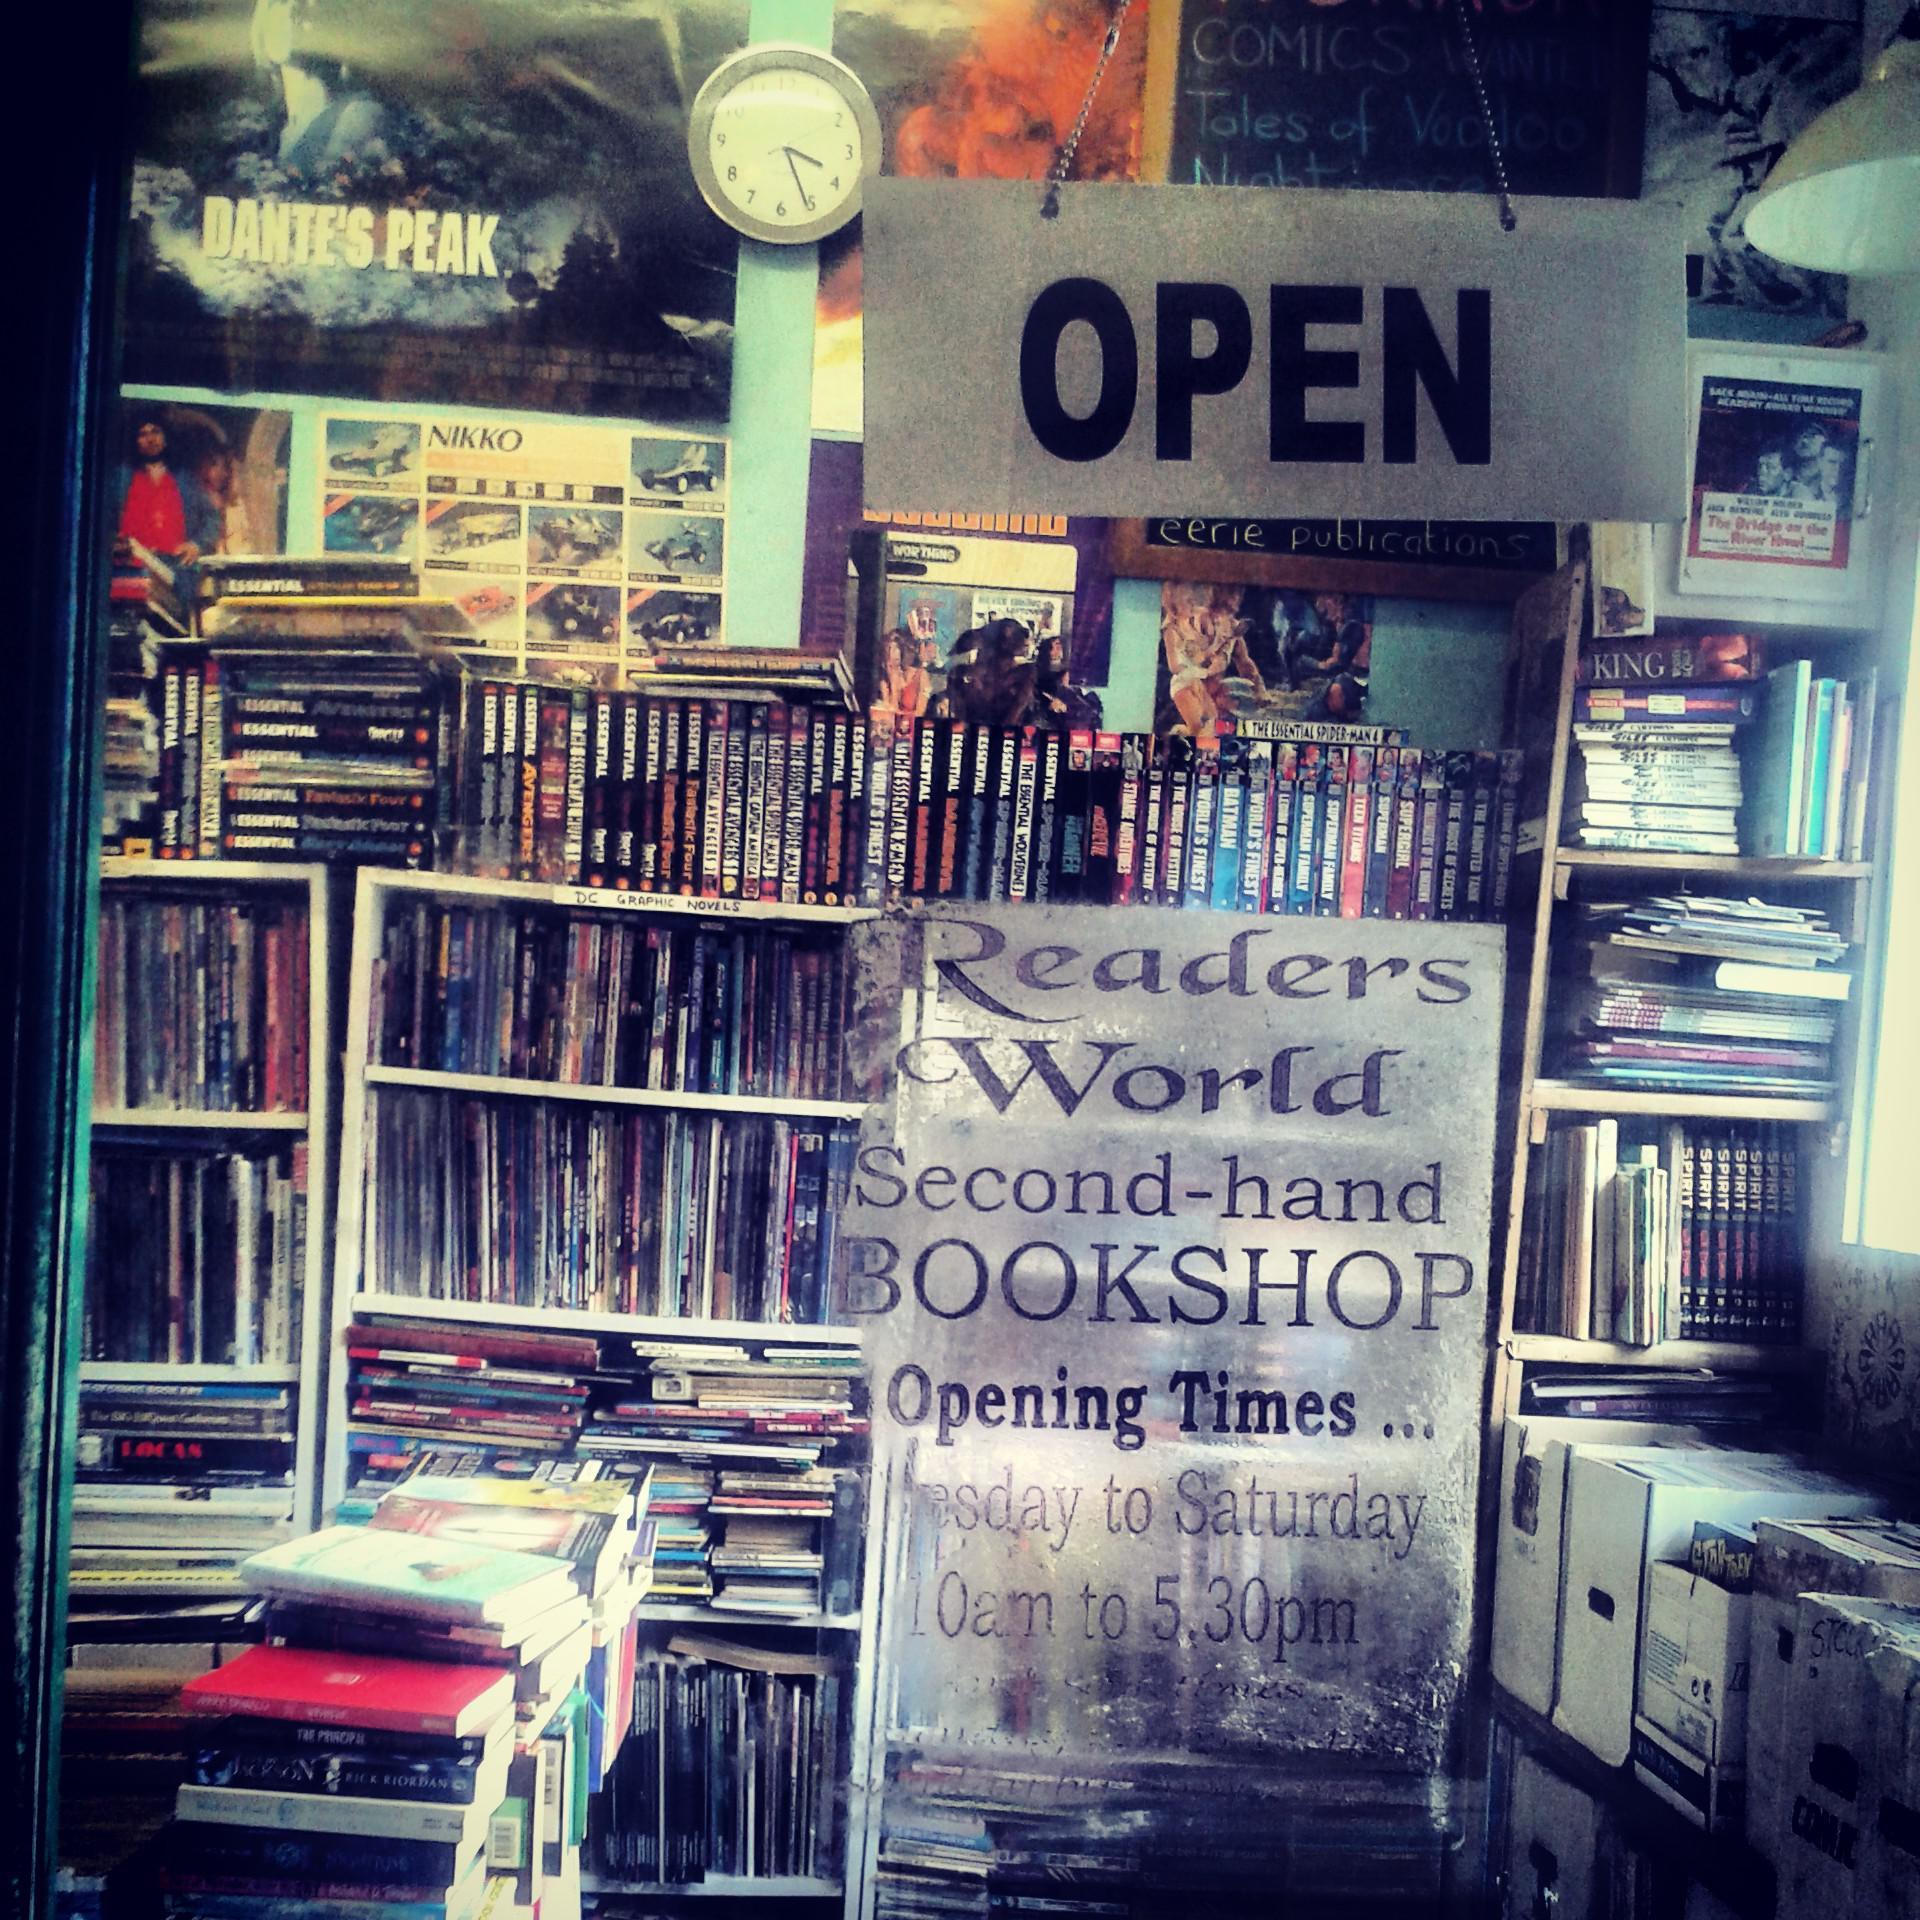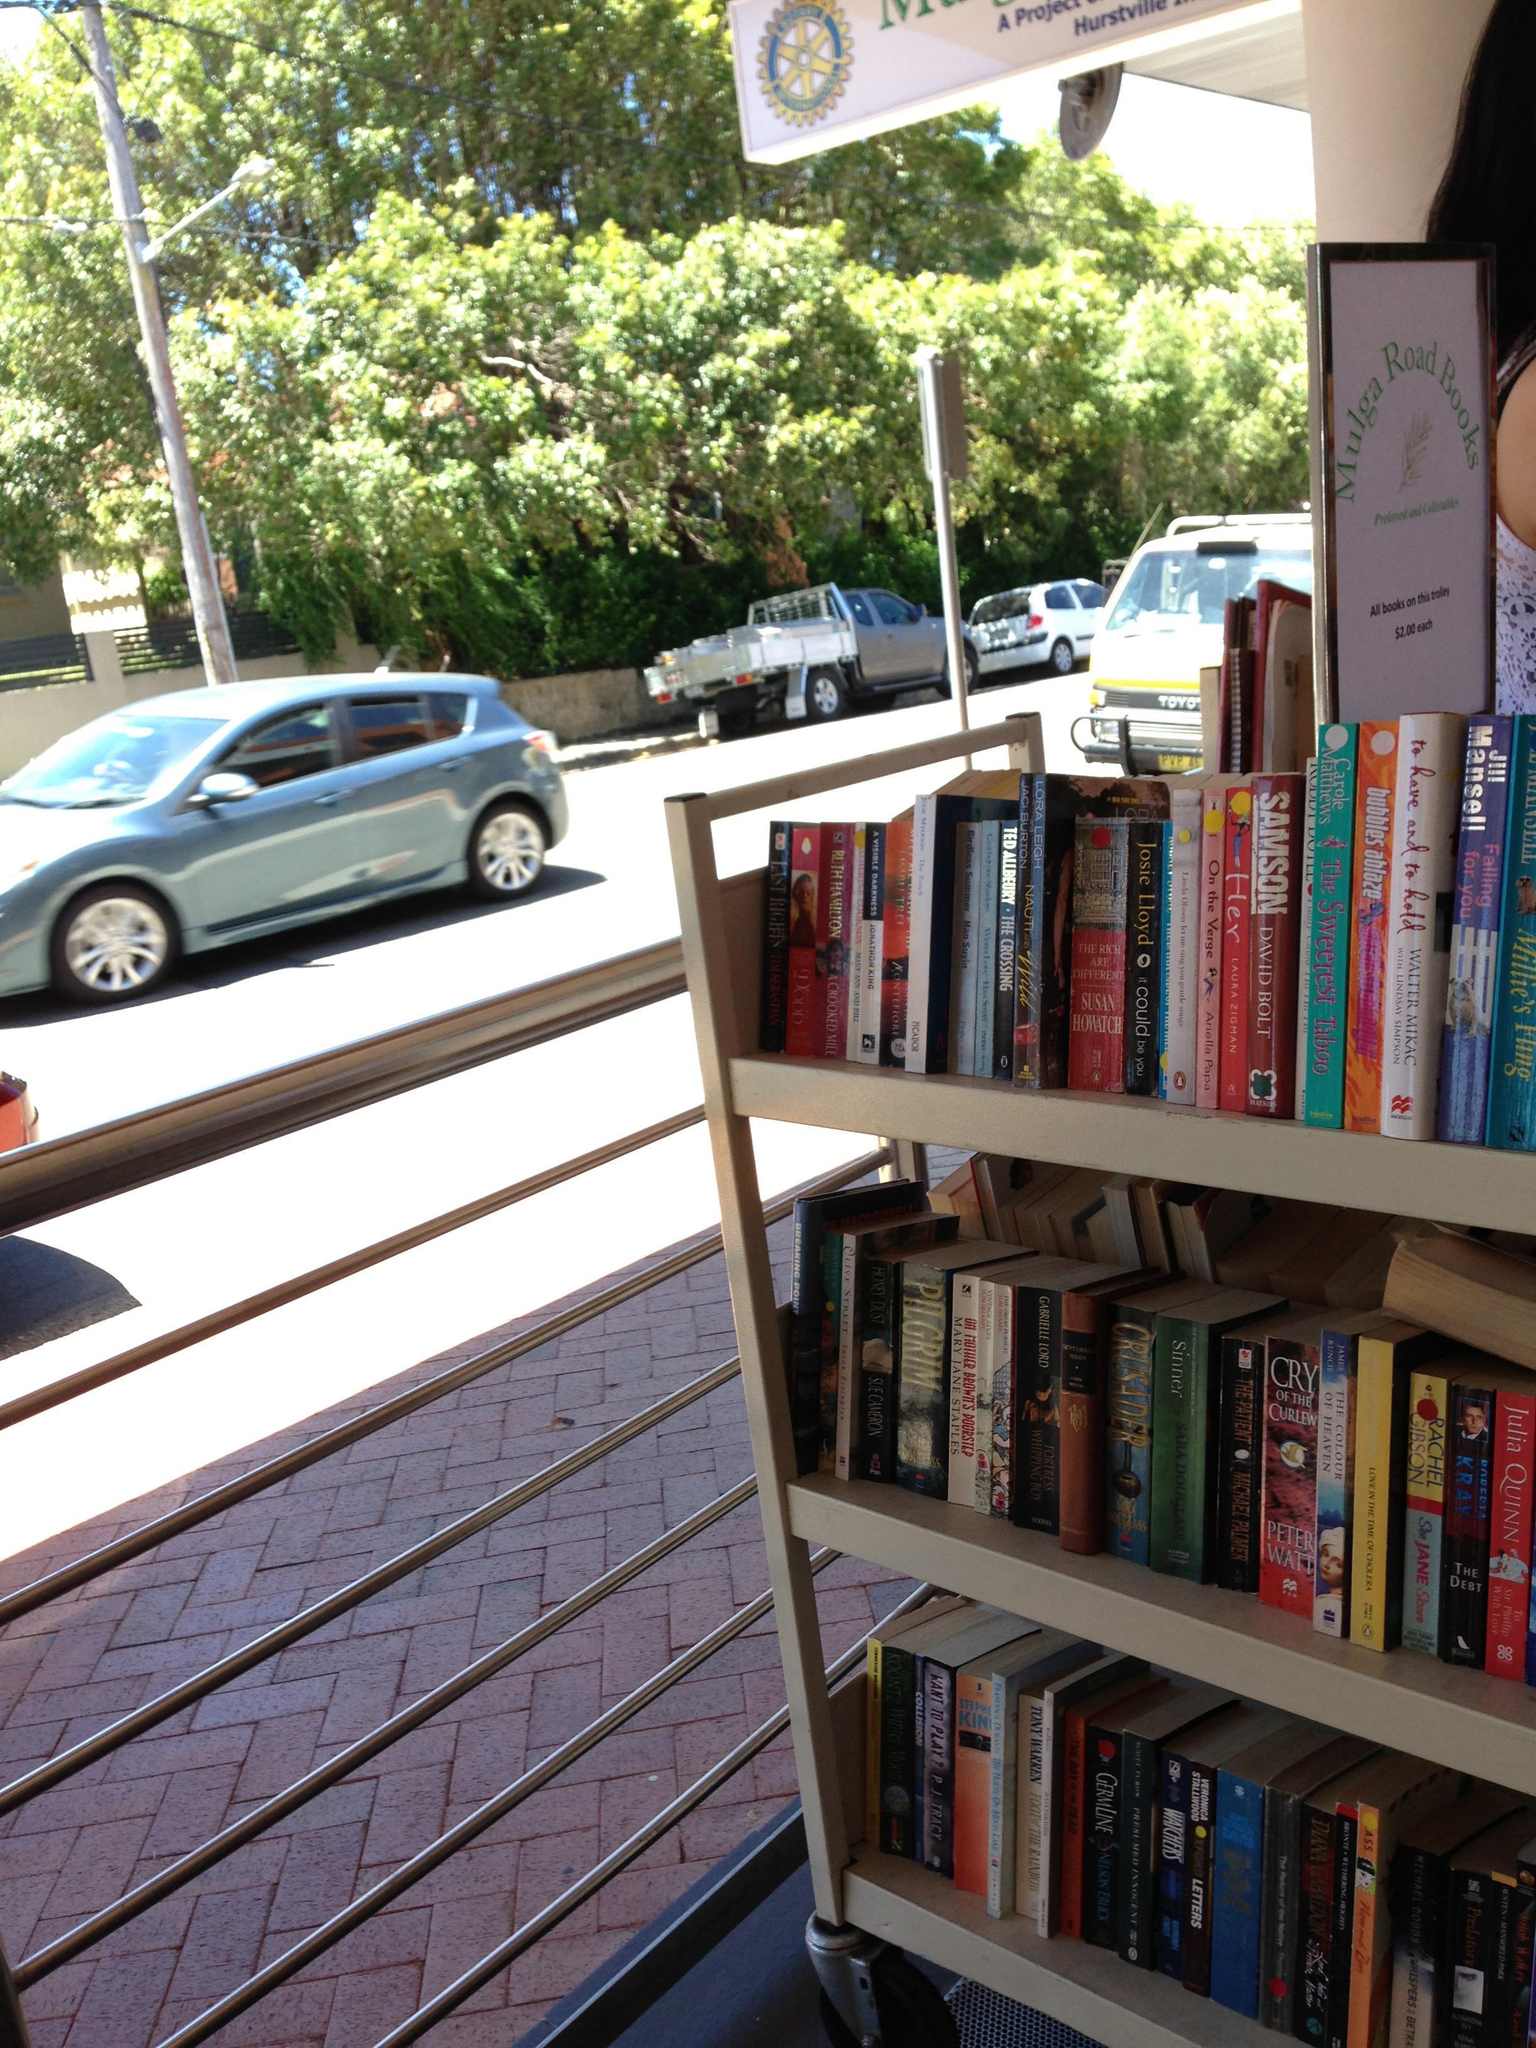The first image is the image on the left, the second image is the image on the right. For the images displayed, is the sentence "In one image, a blond woman has an arm around the man next to her, and a woman on the other side of him has her elbow bent, and they are standing in front of books on shelves." factually correct? Answer yes or no. No. The first image is the image on the left, the second image is the image on the right. Examine the images to the left and right. Is the description "An author is posing with fans." accurate? Answer yes or no. No. 